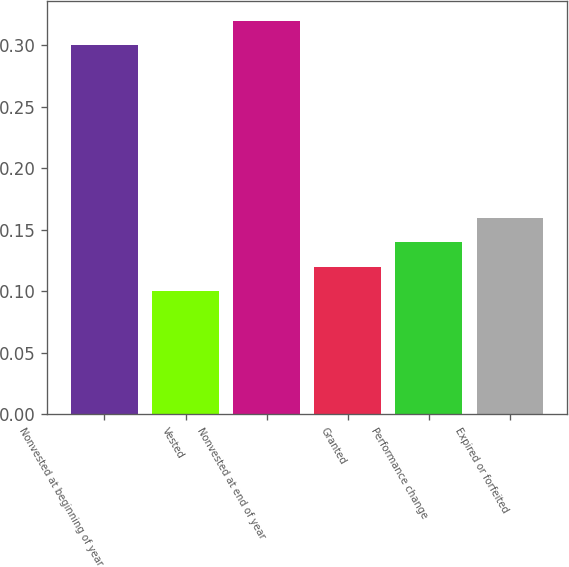<chart> <loc_0><loc_0><loc_500><loc_500><bar_chart><fcel>Nonvested at beginning of year<fcel>Vested<fcel>Nonvested at end of year<fcel>Granted<fcel>Performance change<fcel>Expired or forfeited<nl><fcel>0.3<fcel>0.1<fcel>0.32<fcel>0.12<fcel>0.14<fcel>0.16<nl></chart> 